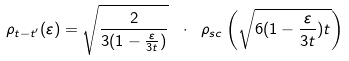Convert formula to latex. <formula><loc_0><loc_0><loc_500><loc_500>\rho _ { t - t ^ { \prime } } ( \varepsilon ) = \sqrt { \frac { 2 } { 3 ( 1 - \frac { \varepsilon } { 3 t } ) } } \ \cdot \ \rho _ { s c } \left ( \sqrt { 6 ( 1 - \frac { \varepsilon } { 3 t } ) t } \right )</formula> 